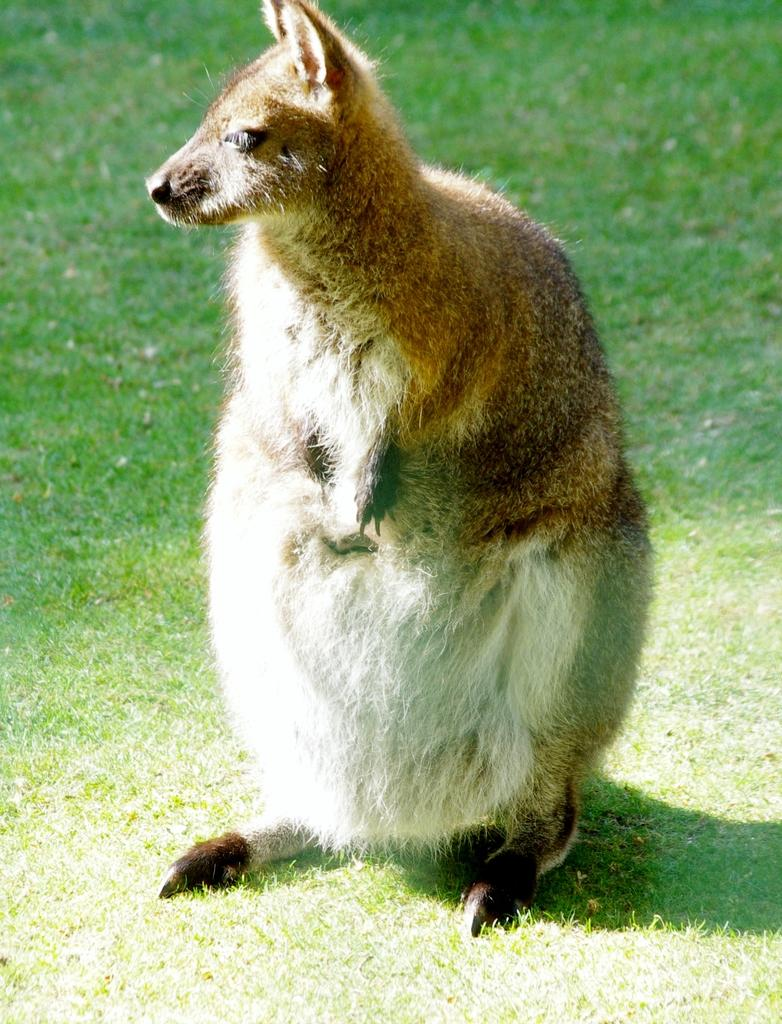What type of animal is in the image? There is a wallaby in the image. Where is the wallaby located? The wallaby is in the grass. What type of soda is the wallaby drinking in the image? There is no soda present in the image; the wallaby is in the grass. Can you hear the wallaby making any sounds in the image? The image is silent, so it is not possible to determine if the wallaby is making any sounds. 